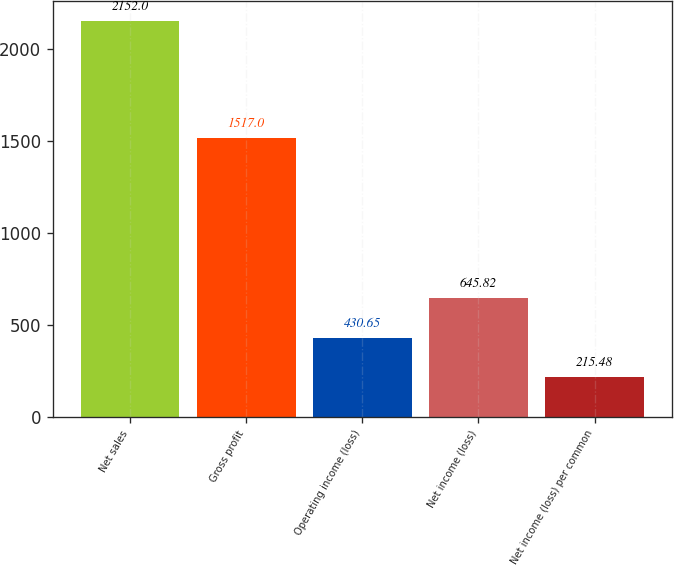Convert chart to OTSL. <chart><loc_0><loc_0><loc_500><loc_500><bar_chart><fcel>Net sales<fcel>Gross profit<fcel>Operating income (loss)<fcel>Net income (loss)<fcel>Net income (loss) per common<nl><fcel>2152<fcel>1517<fcel>430.65<fcel>645.82<fcel>215.48<nl></chart> 